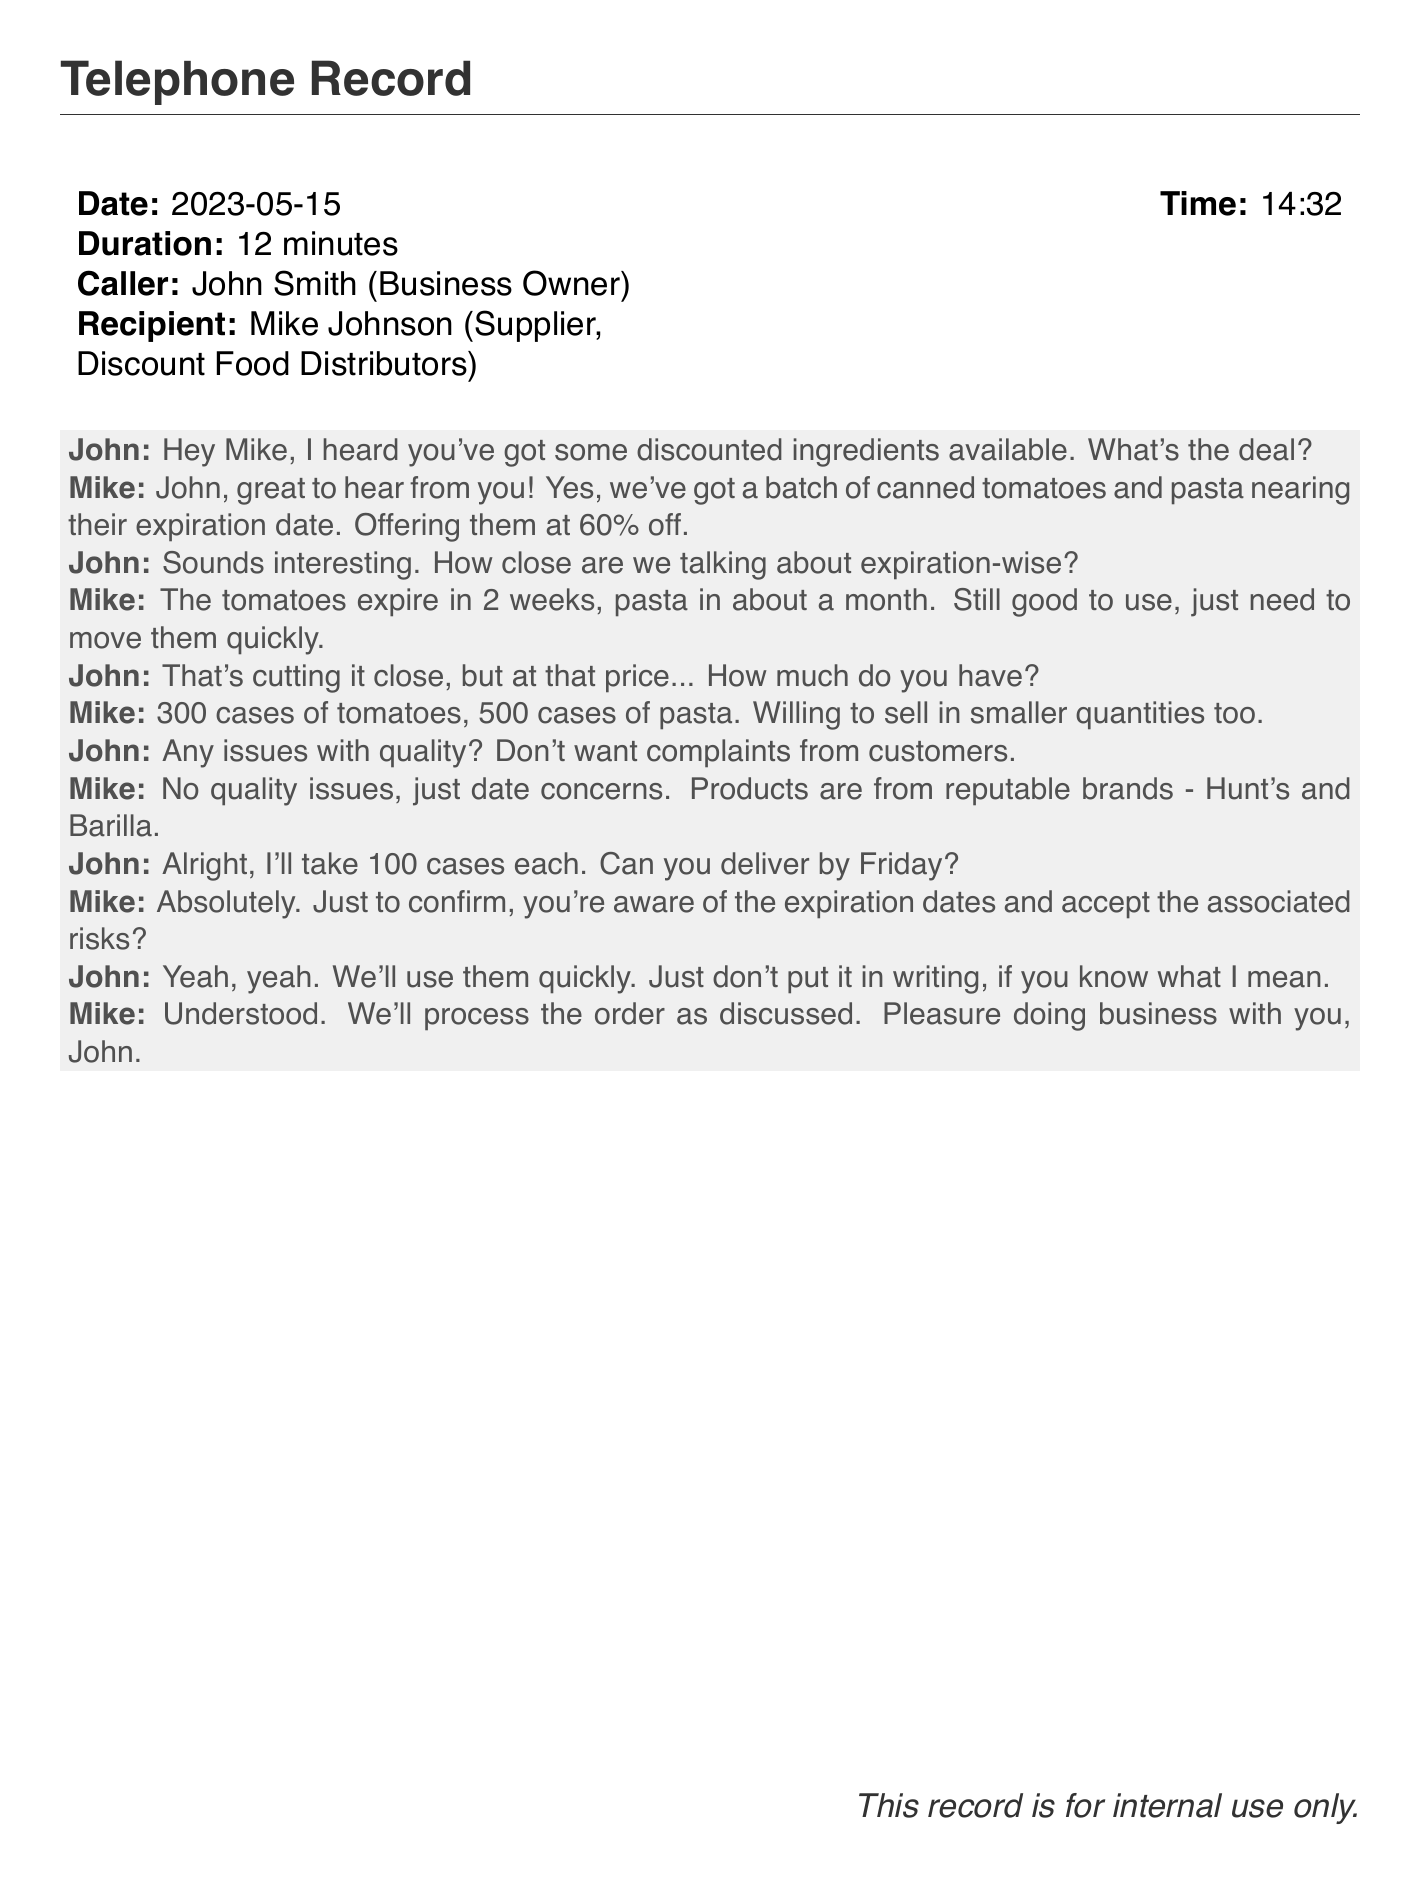What is the date of the call? The date of the call is provided in the telephone record section, which states it is May 15, 2023.
Answer: 2023-05-15 Who is the caller? The caller's name is listed as John Smith in the document.
Answer: John Smith How long did the conversation last? The duration of the conversation is explicitly mentioned in the document, which states it lasted 12 minutes.
Answer: 12 minutes What products were discussed? The document specifies that canned tomatoes and pasta were the products being discussed.
Answer: Canned tomatoes and pasta What discount was offered on the products? The discounted rate is noted in the document to be 60% off.
Answer: 60% When do the tomatoes expire? The expiration date for the tomatoes is provided as two weeks from the time of the call.
Answer: In 2 weeks How many cases of pasta did John order? The document includes the specific quantity that John decided to order, which is noted as 100 cases.
Answer: 100 cases What brands are mentioned in the conversation? The conversation records that Hunt's and Barilla were the brands referenced for the products.
Answer: Hunt's and Barilla What does John request regarding the order confirmation? John explicitly requests not to have the details in writing, indicating a preference for informal handling of the order.
Answer: Don't put it in writing 